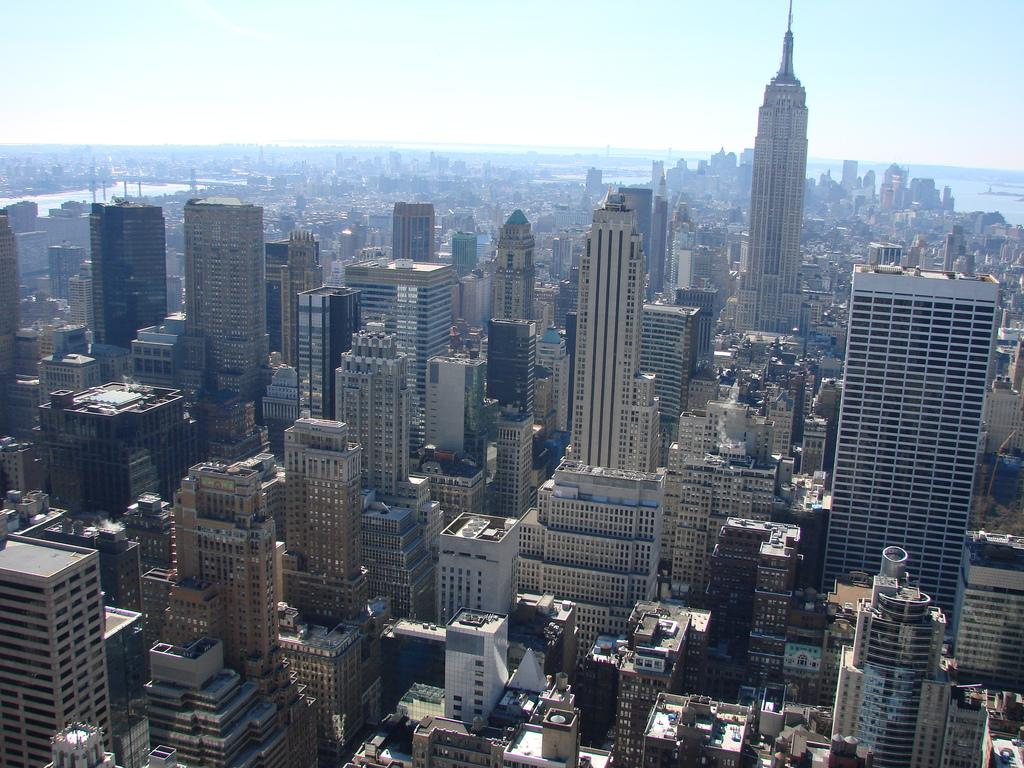What structures are visible in the image? There are multiple buildings in the image. What is visible at the top side of the image? The sky is visible at the top side of the image. What type of fish can be seen swimming in the sky in the image? There are no fish present in the image, and the sky is not a body of water where fish could swim. How many gloves are visible in the image? There are no gloves present in the image. 